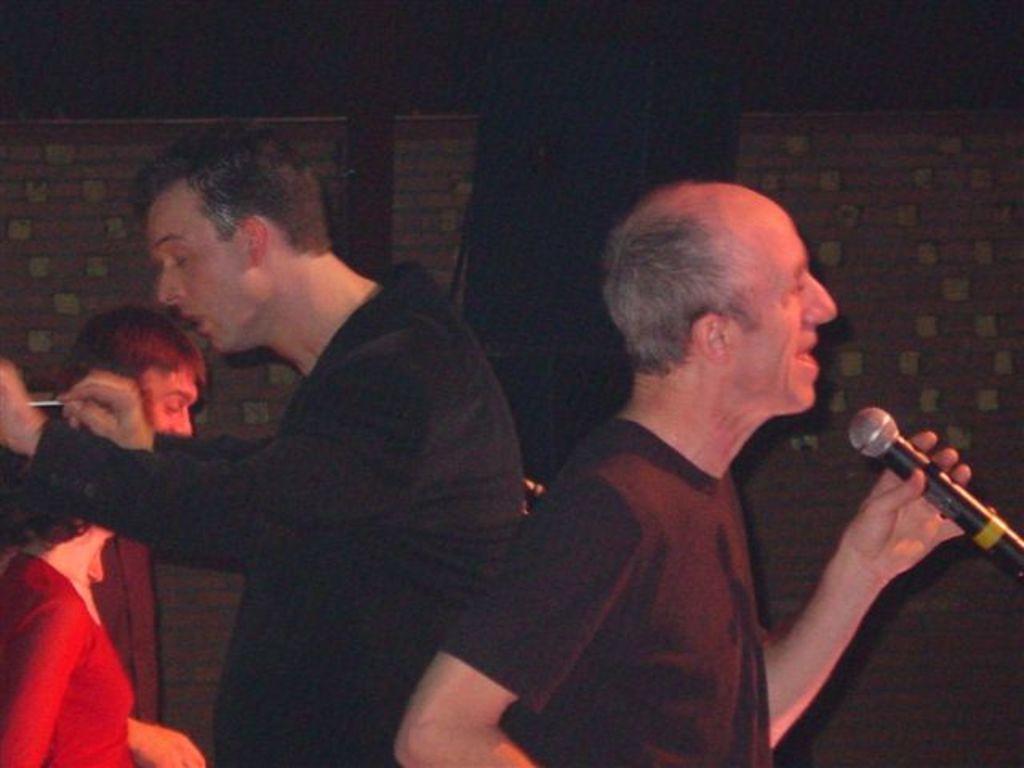Please provide a concise description of this image. In this image there is a man on the right side who is holding the mic. Behind him there is another person. In the background there is a wall on which there is some design. In the middle there is a black color cloth. There are two other persons on the left side. 